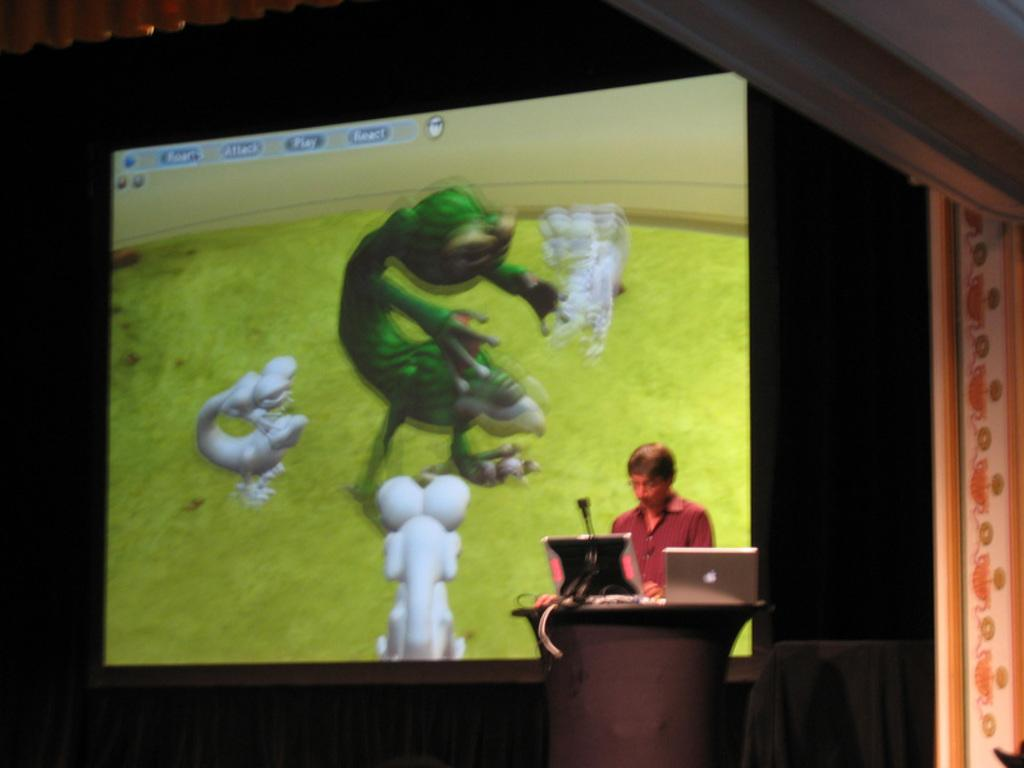What is the person in the image doing? The person is standing in front of a podium. What objects are in front of the person? There are two laptops and a microphone in front of the person. What can be seen in the background of the image? There is a projector screen in the background. Can you see a frog sitting on the podium in the image? No, there is no frog present in the image. What type of tent is set up behind the person in the image? There is no tent present in the image. 